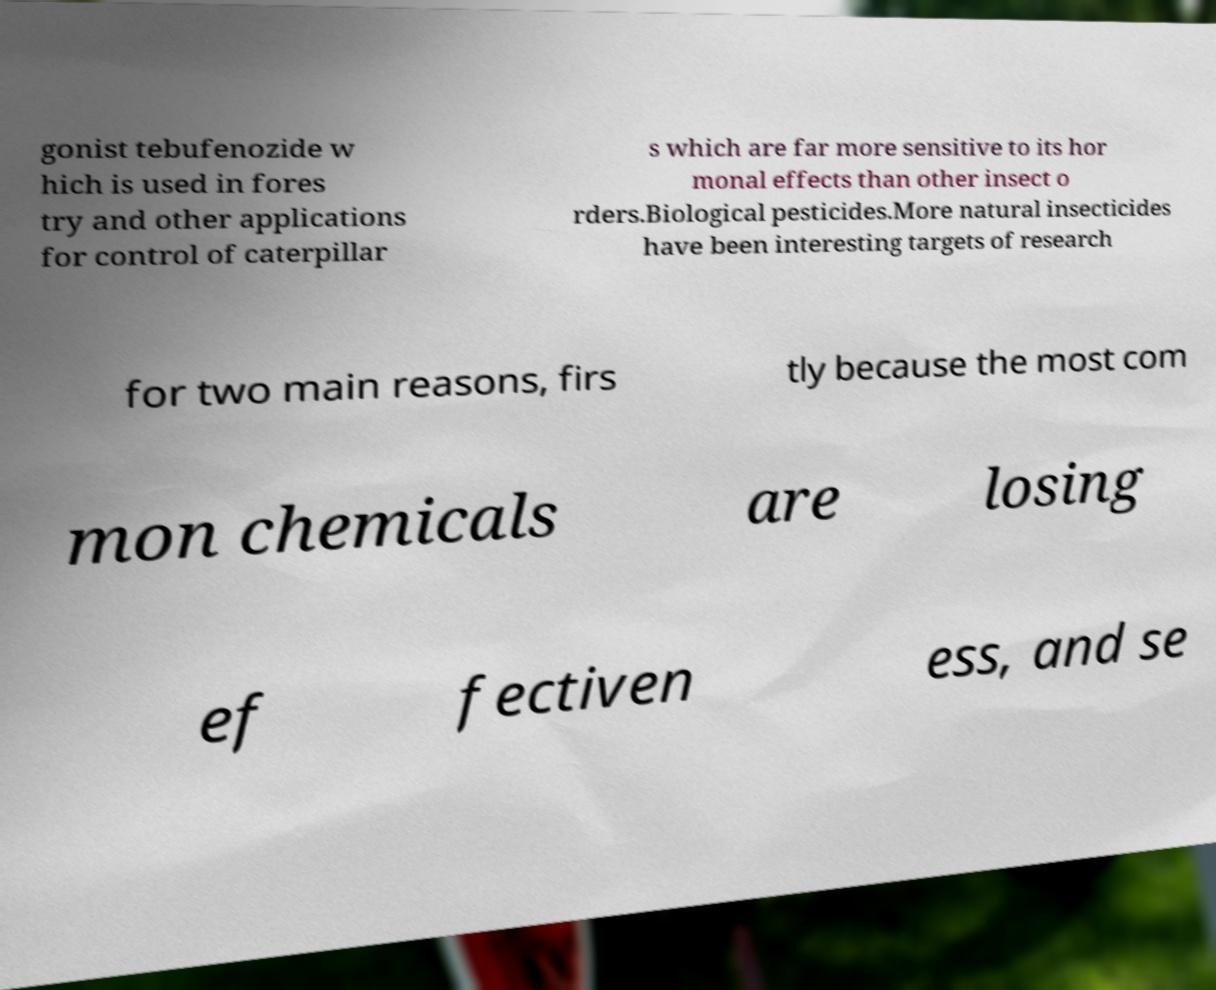What messages or text are displayed in this image? I need them in a readable, typed format. gonist tebufenozide w hich is used in fores try and other applications for control of caterpillar s which are far more sensitive to its hor monal effects than other insect o rders.Biological pesticides.More natural insecticides have been interesting targets of research for two main reasons, firs tly because the most com mon chemicals are losing ef fectiven ess, and se 